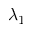<formula> <loc_0><loc_0><loc_500><loc_500>\lambda _ { 1 }</formula> 